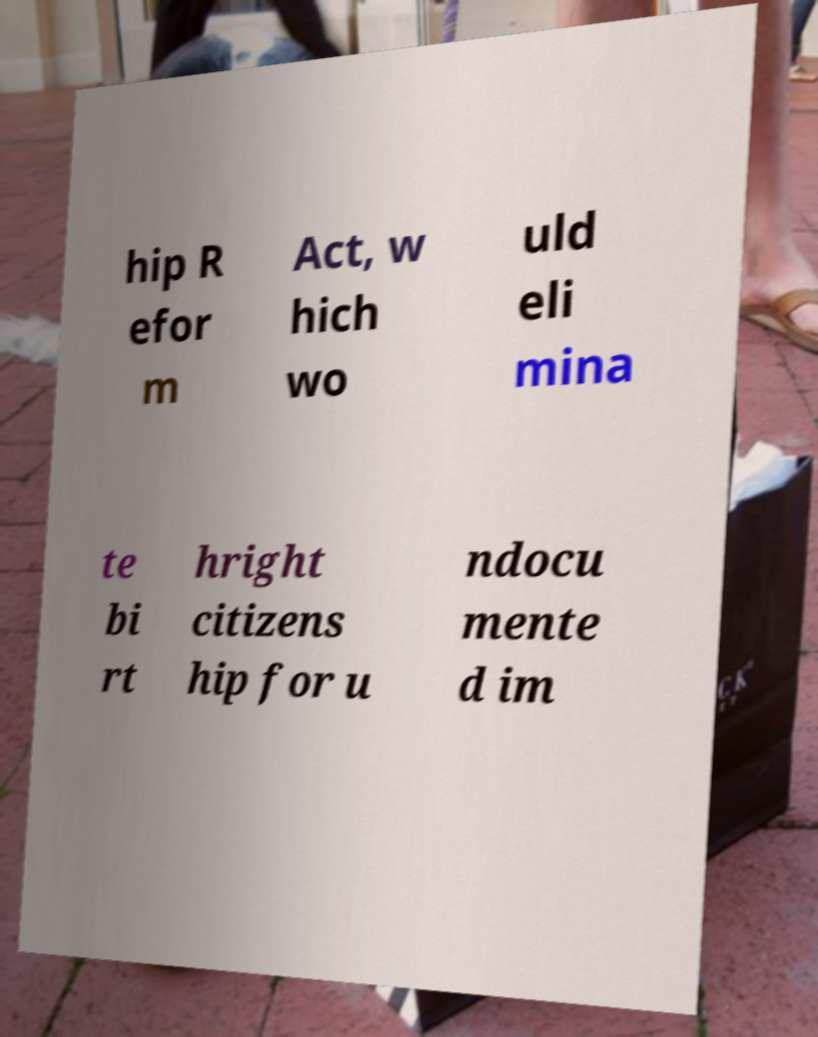Can you read and provide the text displayed in the image?This photo seems to have some interesting text. Can you extract and type it out for me? hip R efor m Act, w hich wo uld eli mina te bi rt hright citizens hip for u ndocu mente d im 